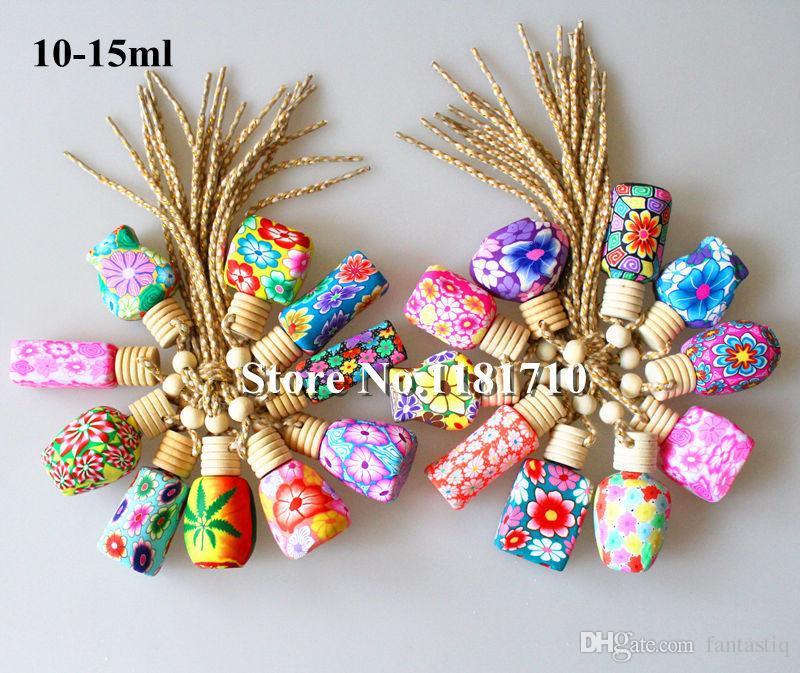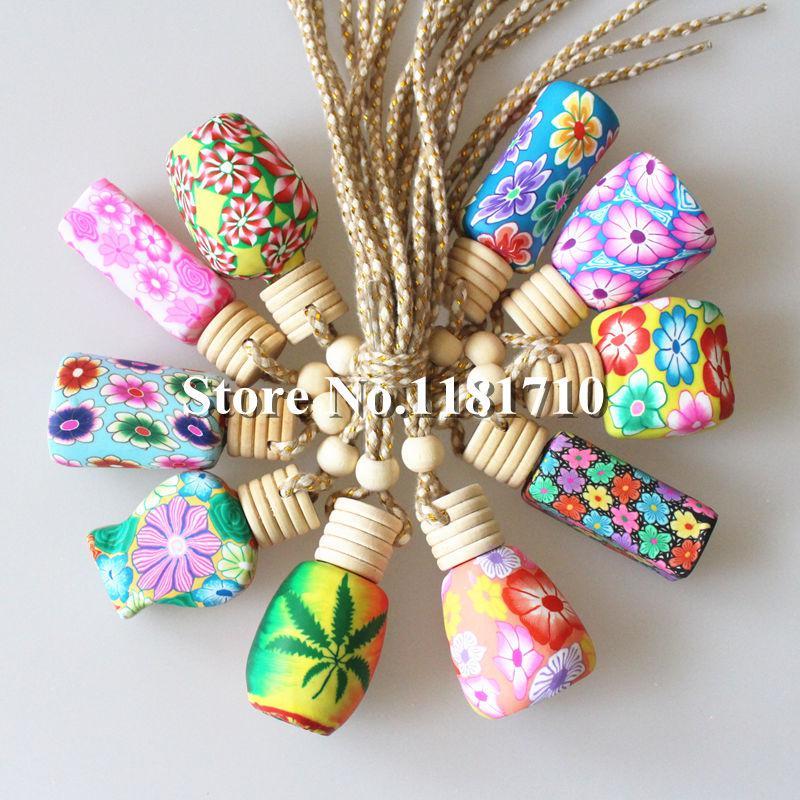The first image is the image on the left, the second image is the image on the right. Examine the images to the left and right. Is the description "At least 4 bottles are lined up in a straight row." accurate? Answer yes or no. No. The first image is the image on the left, the second image is the image on the right. Given the left and right images, does the statement "All bottles have wooden caps and at least one bottle has a braided strap attached." hold true? Answer yes or no. Yes. 